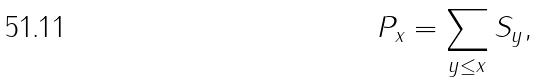<formula> <loc_0><loc_0><loc_500><loc_500>P _ { x } = \sum _ { y \leq x } S _ { y } ,</formula> 